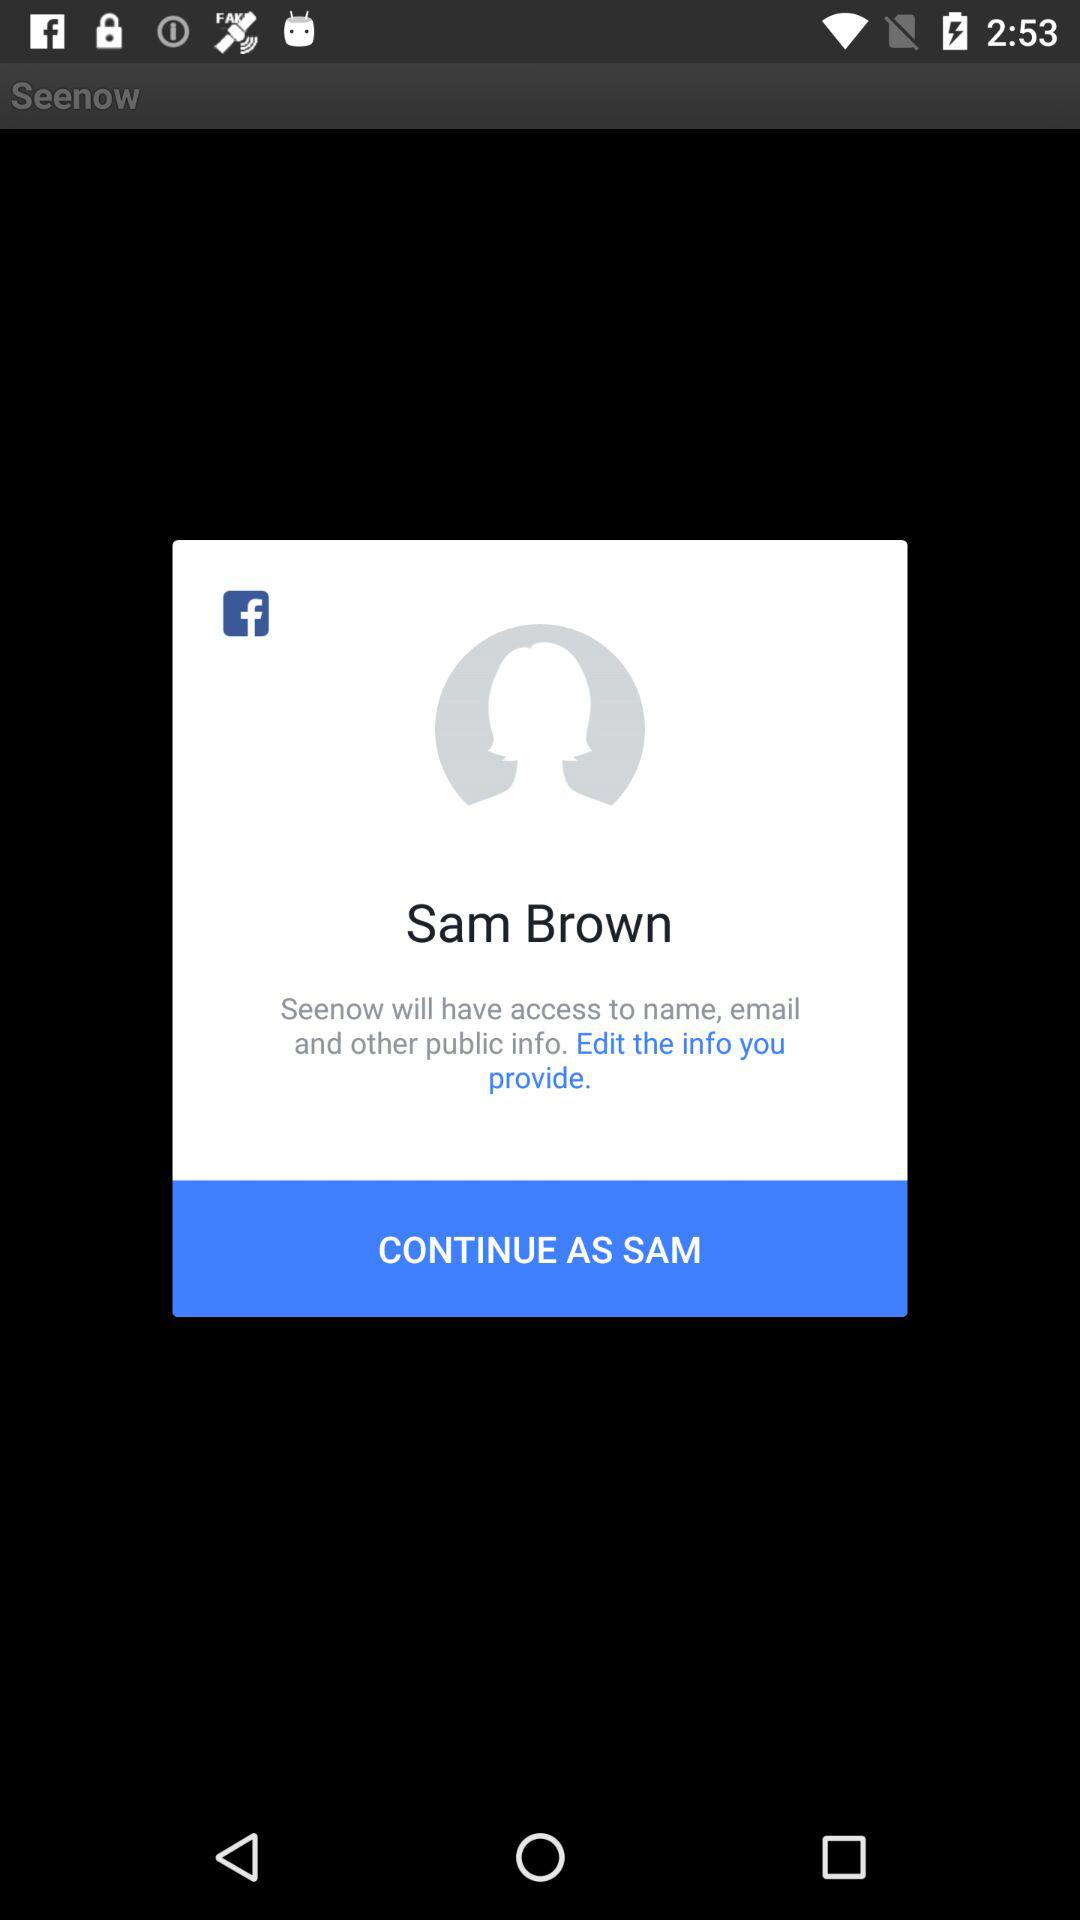Is the provided information edited?
When the provided information is insufficient, respond with <no answer>. <no answer> 